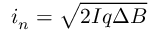Convert formula to latex. <formula><loc_0><loc_0><loc_500><loc_500>i _ { n } = { \sqrt { 2 I q \Delta B } }</formula> 